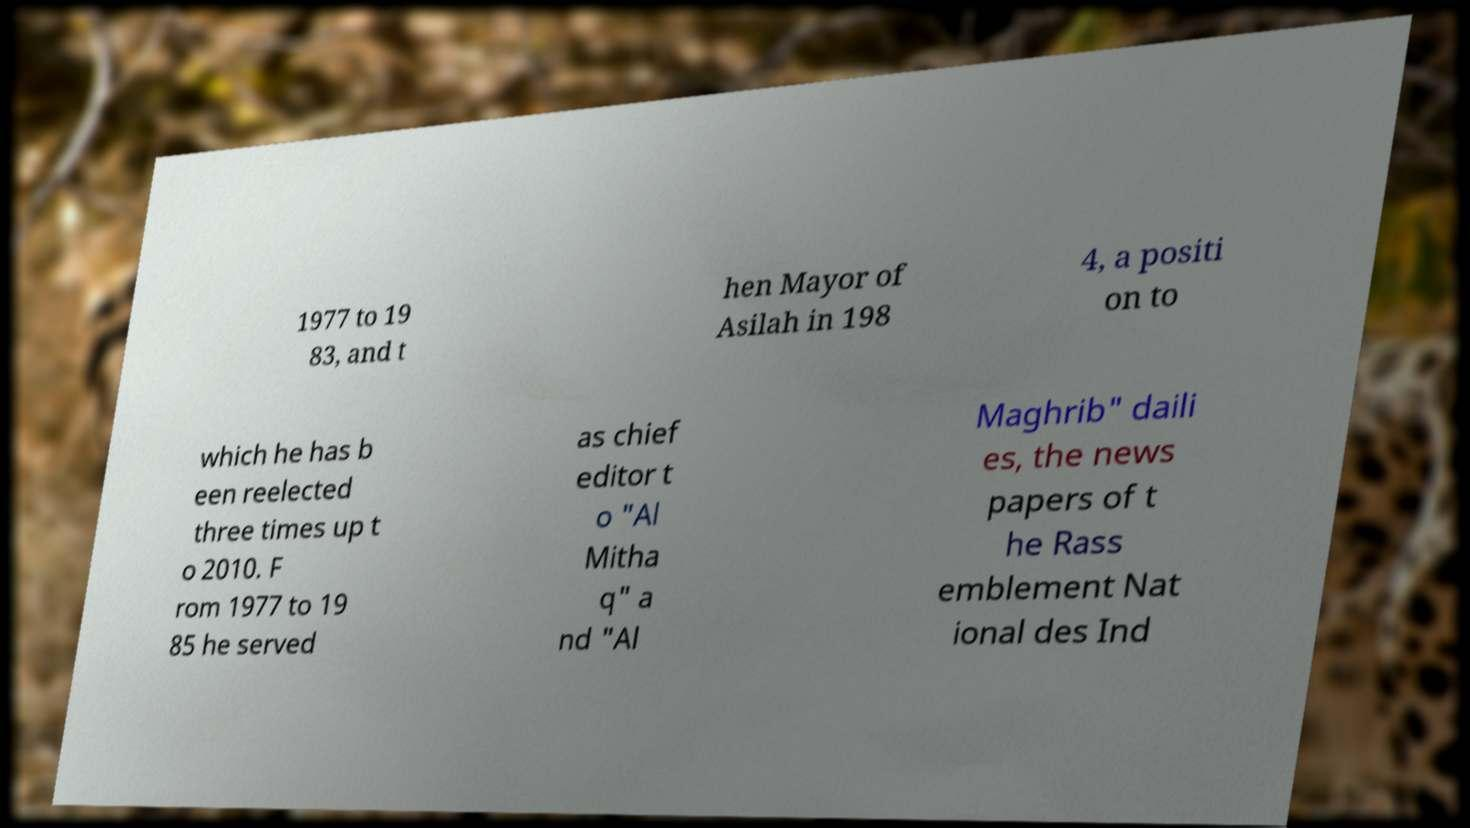Please identify and transcribe the text found in this image. 1977 to 19 83, and t hen Mayor of Asilah in 198 4, a positi on to which he has b een reelected three times up t o 2010. F rom 1977 to 19 85 he served as chief editor t o "Al Mitha q" a nd "Al Maghrib" daili es, the news papers of t he Rass emblement Nat ional des Ind 